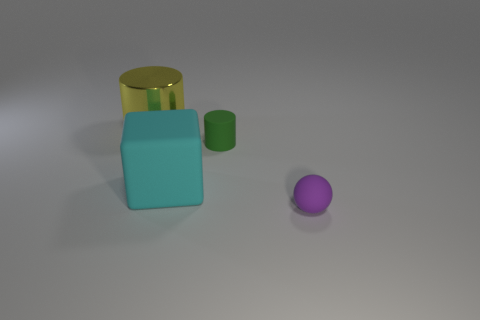Add 3 small purple rubber things. How many objects exist? 7 Subtract all green cylinders. How many cylinders are left? 1 Subtract all red metallic cylinders. Subtract all yellow metallic things. How many objects are left? 3 Add 2 rubber cylinders. How many rubber cylinders are left? 3 Add 3 large blue metallic blocks. How many large blue metallic blocks exist? 3 Subtract 0 brown balls. How many objects are left? 4 Subtract all yellow cylinders. Subtract all brown balls. How many cylinders are left? 1 